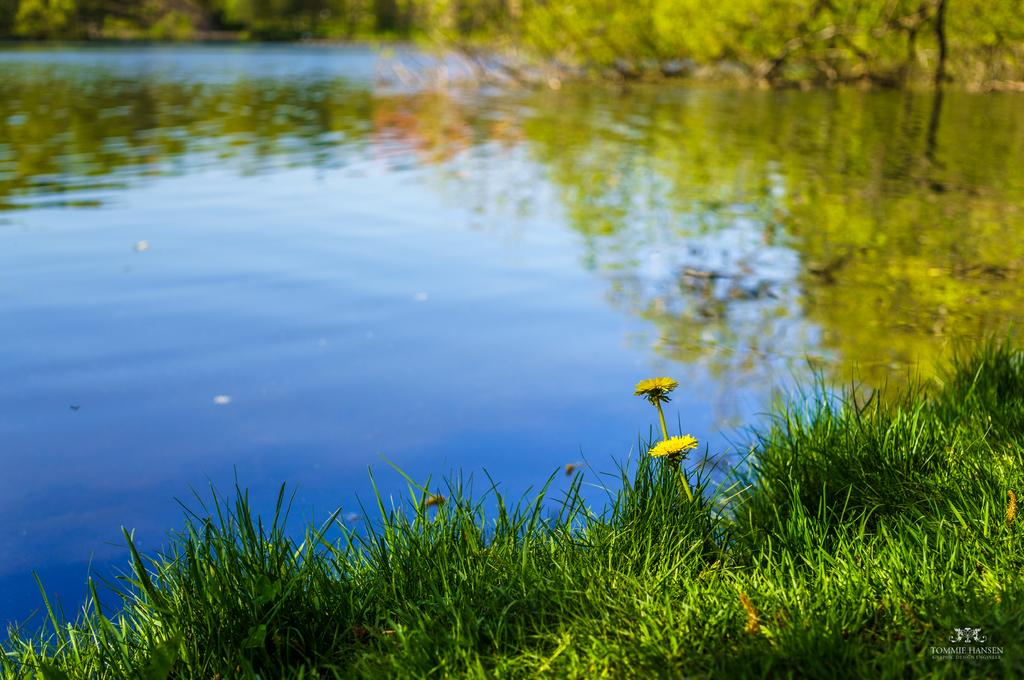What type of vegetation can be seen in the image? There is grass in the image. Are there any flowers present in the image? Yes, there are yellow flowers in the image. What can be seen in the background of the image? There is water and trees visible in the background of the image. What type of jeans can be seen in the image? There are no jeans present in the image. Is there any indication of an attack happening in the image? There is no indication of an attack in the image; it features grass, yellow flowers, water, and trees. 